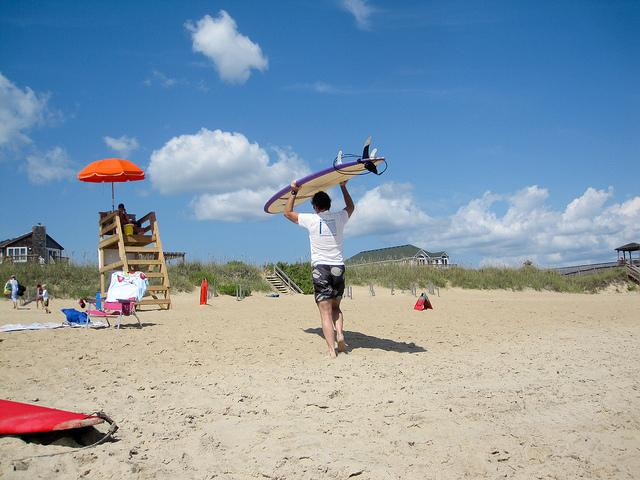What kind of view might be seen from the windows on the house? Please explain your reasoning. sea view. A man is caring a surfboard on a beach. the ocean can be seen from many beaches. 